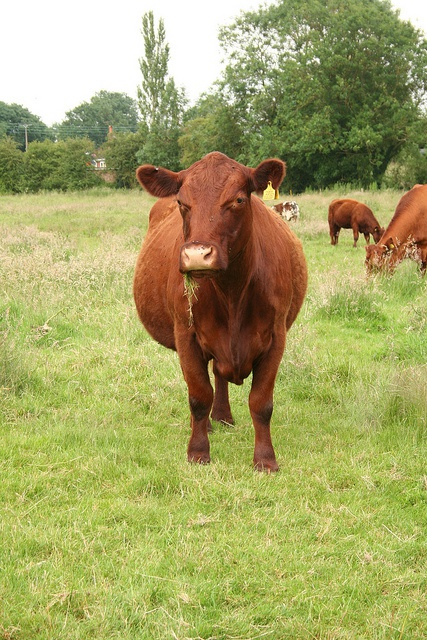Describe the objects in this image and their specific colors. I can see cow in white, maroon, brown, and black tones, cow in white, brown, tan, salmon, and red tones, cow in white, maroon, brown, and black tones, and cow in white, tan, and beige tones in this image. 